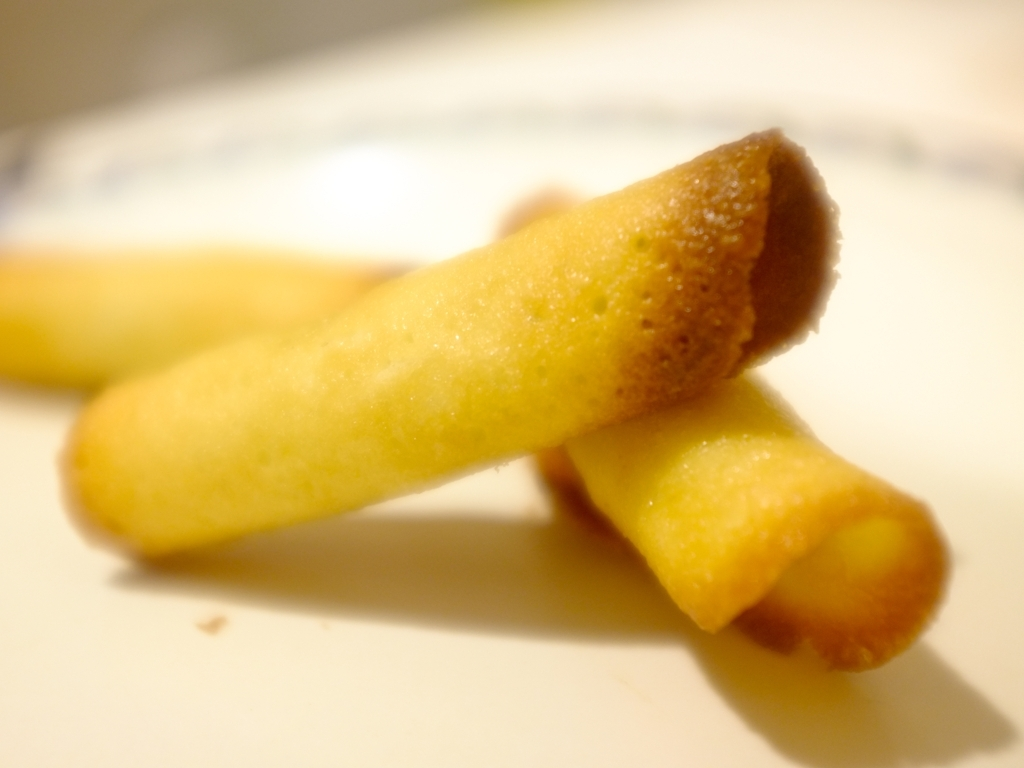Can you suggest a setting or occasion where this food might be served? This type of sweet treat could be elegantly served as part of a dessert platter at an afternoon tea, a special celebration like a birthday party, or as a delicate accompaniment to coffee or ice cream in a more casual setting. Does the image provide any clues about the origin of the snack? While the image doesn't give away the specific origin of the snack, rolled wafers like these are often associated with European confections, particularly from countries like Italy or France where such desserts are a traditional treat. 